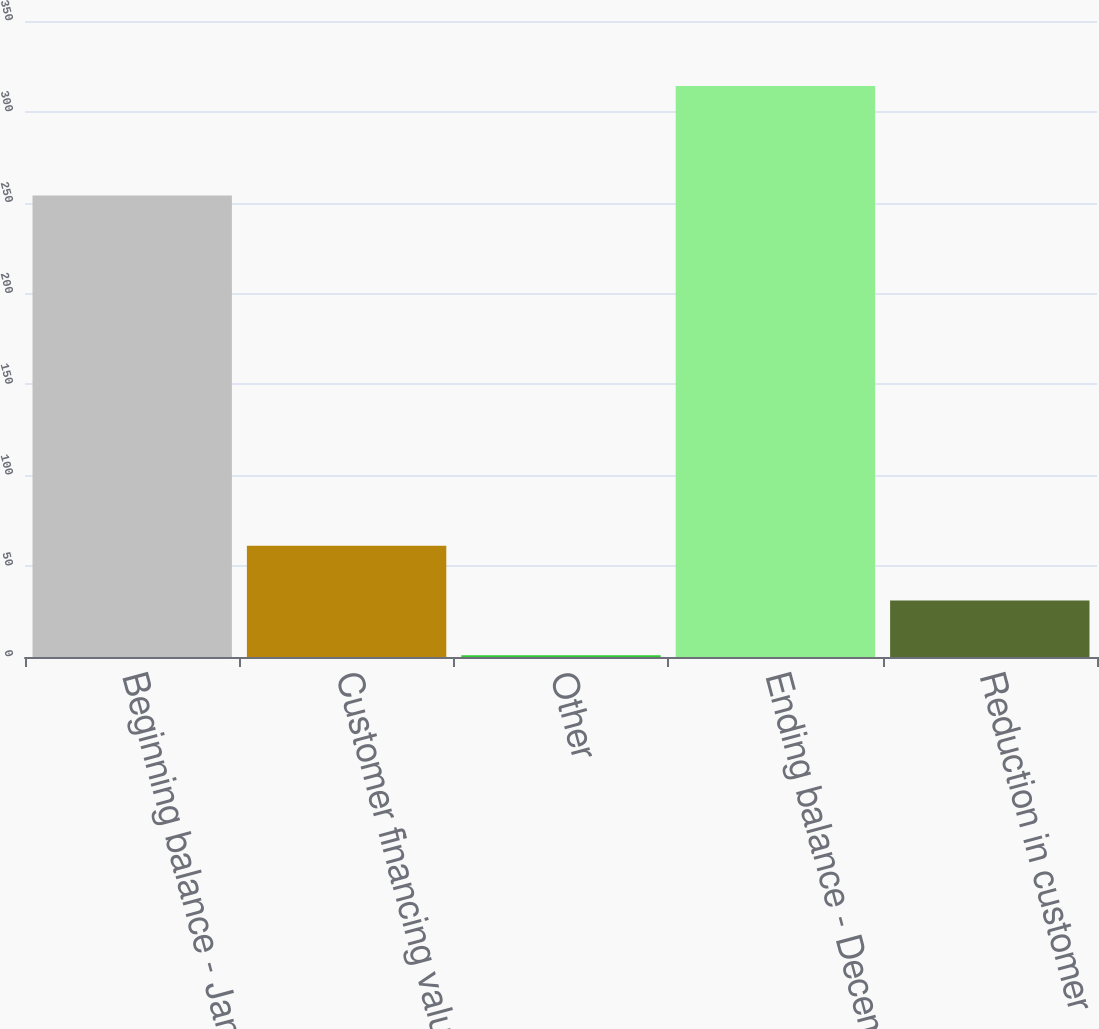<chart> <loc_0><loc_0><loc_500><loc_500><bar_chart><fcel>Beginning balance - January 1<fcel>Customer financing valuation<fcel>Other<fcel>Ending balance - December 31<fcel>Reduction in customer<nl><fcel>254<fcel>61.2<fcel>1<fcel>314.2<fcel>31.1<nl></chart> 